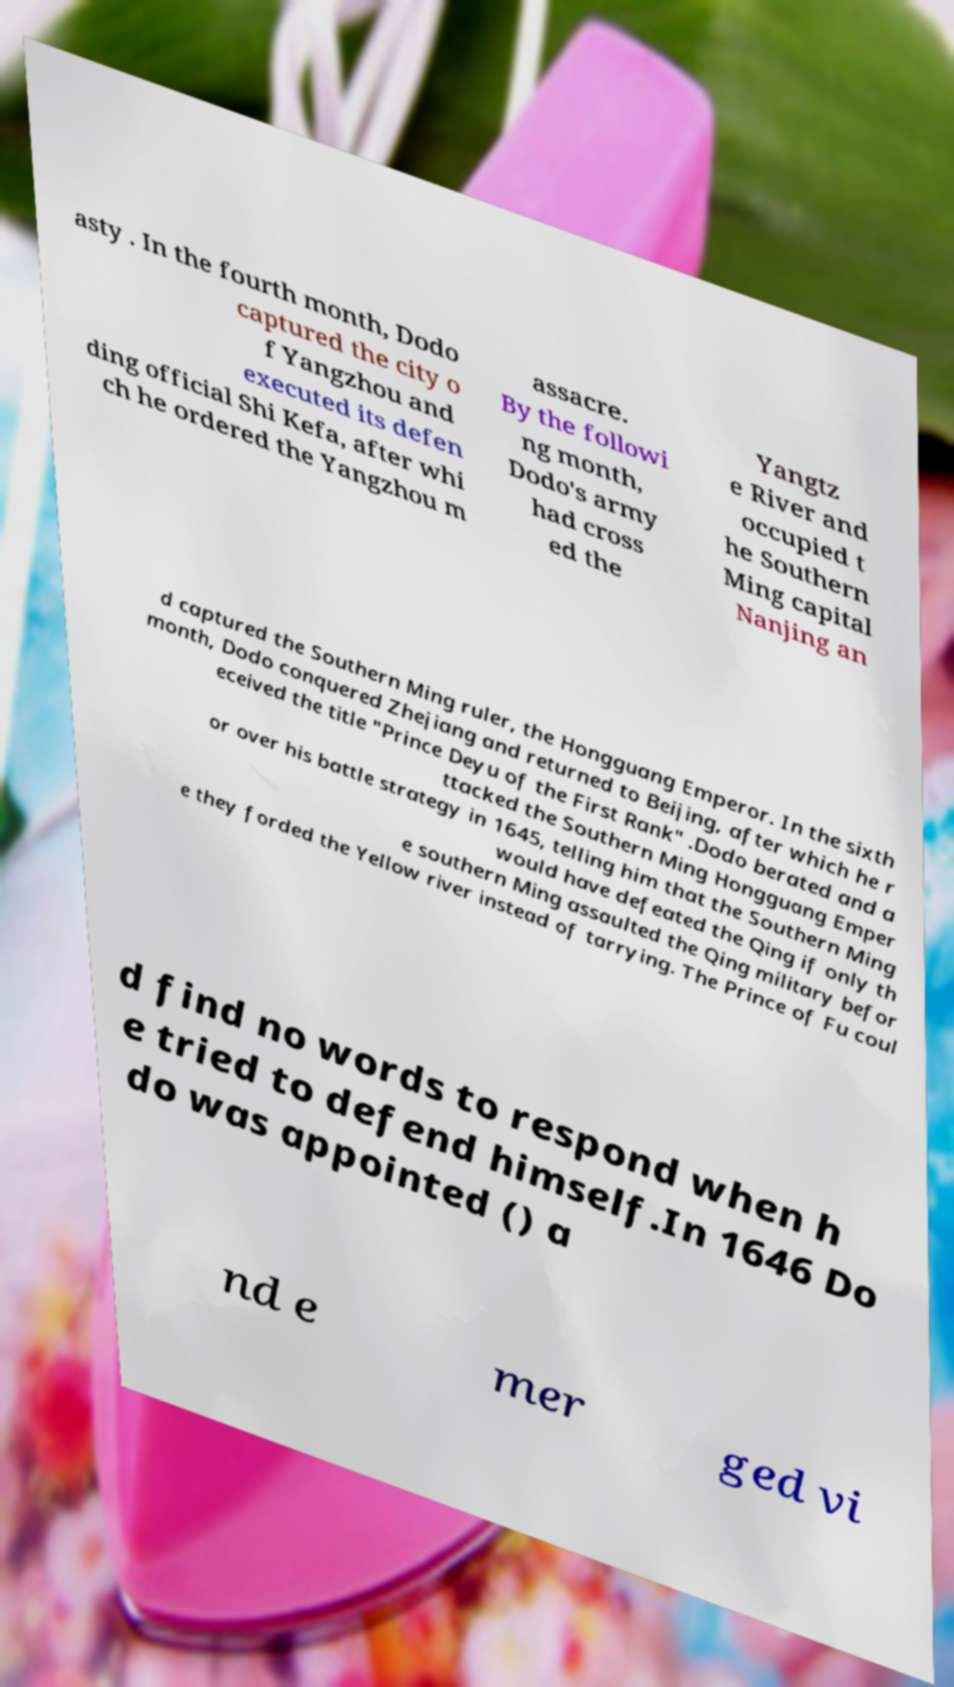Could you assist in decoding the text presented in this image and type it out clearly? asty . In the fourth month, Dodo captured the city o f Yangzhou and executed its defen ding official Shi Kefa, after whi ch he ordered the Yangzhou m assacre. By the followi ng month, Dodo's army had cross ed the Yangtz e River and occupied t he Southern Ming capital Nanjing an d captured the Southern Ming ruler, the Hongguang Emperor. In the sixth month, Dodo conquered Zhejiang and returned to Beijing, after which he r eceived the title "Prince Deyu of the First Rank" .Dodo berated and a ttacked the Southern Ming Hongguang Emper or over his battle strategy in 1645, telling him that the Southern Ming would have defeated the Qing if only th e southern Ming assaulted the Qing military befor e they forded the Yellow river instead of tarrying. The Prince of Fu coul d find no words to respond when h e tried to defend himself.In 1646 Do do was appointed () a nd e mer ged vi 